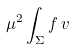<formula> <loc_0><loc_0><loc_500><loc_500>\mu ^ { 2 } \int _ { \Sigma } f \, v</formula> 